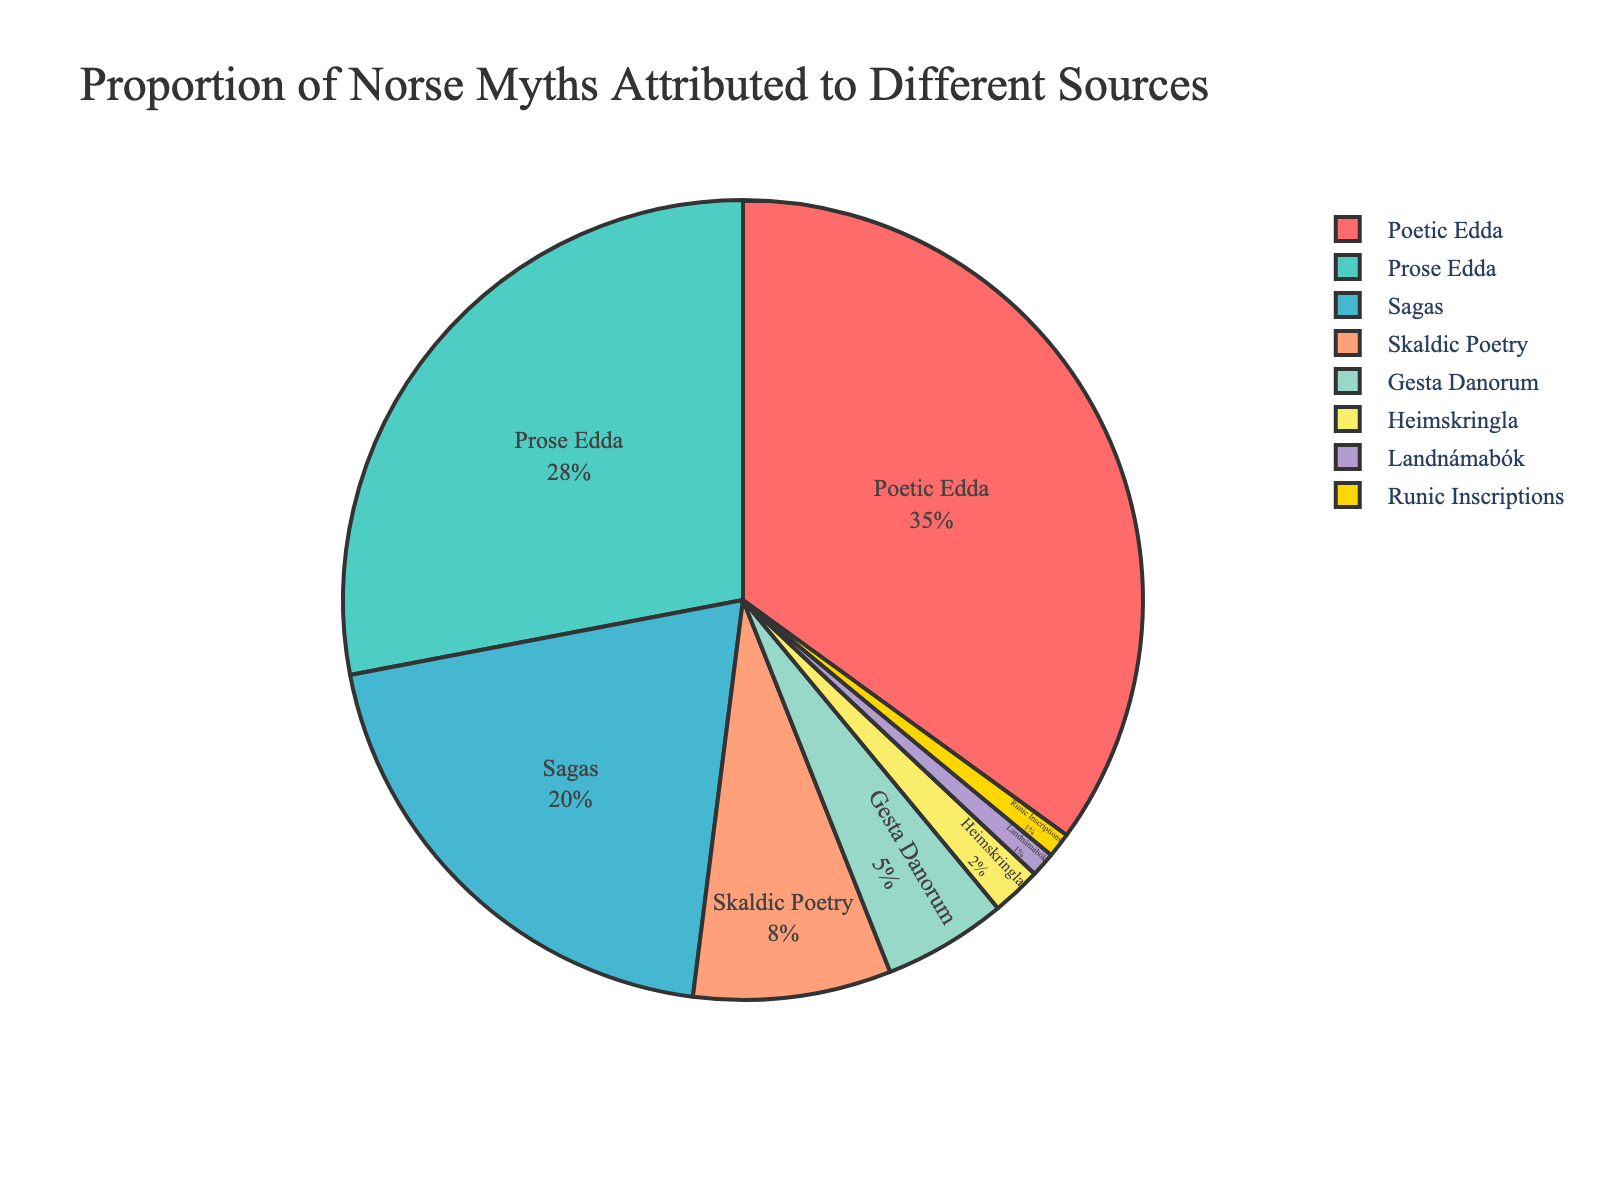What is the largest source of Norse myths by percentage? The largest segment in the pie chart represents the Poetic Edda. It has the highest percentage attributed to Norse myths.
Answer: Poetic Edda Compare the proportions of Prose Edda and Sagas. Which one is greater, and by how much? The Prose Edda has 28% while the Sagas have 20%. The difference between them is calculated as 28% - 20% = 8%.
Answer: Prose Edda by 8% Calculate the combined percentage of Norse myths from Poetic Edda and Prose Edda. Poetic Edda contributes 35% and Prose Edda contributes 28%. Adding these percentages gives 35% + 28% = 63%.
Answer: 63% Which source has the smallest proportion of Norse myths? The smallest segments in the pie chart are for Runic Inscriptions and Landnámabók, each contributing 1%. Since they are equally small, either can be considered the smallest.
Answer: Runic Inscriptions or Landnámabók Does Skaldic Poetry have a greater or lesser percentage than Gesta Danorum, and by what margin? Skaldic Poetry has 8% whereas Gesta Danorum has 5%. The difference is calculated as 8% - 5% = 3%.
Answer: Greater by 3% What is the combined percentage of the three least common sources of Norse myths? The three least common sources are Heimskringla (2%), Landnámabók (1%), and Runic Inscriptions (1%). The combined percentage is 2% + 1% + 1% = 4%.
Answer: 4% Which source contributes more to Norse myths: Sagas or Skaldic Poetry, and by how much? Sagas contribute 20% while Skaldic Poetry contributes 8%. The difference is calculated as 20% - 8% = 12%.
Answer: Sagas by 12% Which colored segment of the pie chart represents the percentage of Norse myths attributed to the Prose Edda? In the pie chart, the segment colored in a unique color second to the largest segment represents Prose Edda.
Answer: Second largest segment What percent of Norse myths are attributed to neither Poetic Edda nor Prose Edda? The combined percentage of Poetic Edda and Prose Edda is 63%. Therefore, the percentage attributed to other sources is 100% - 63% = 37%.
Answer: 37% How much greater is the proportion of myths attributed to the Poetic Edda compared to Heimskringla? Poetic Edda has 35% while Heimskringla has 2%. The difference is calculated as 35% - 2% = 33%.
Answer: 33% 